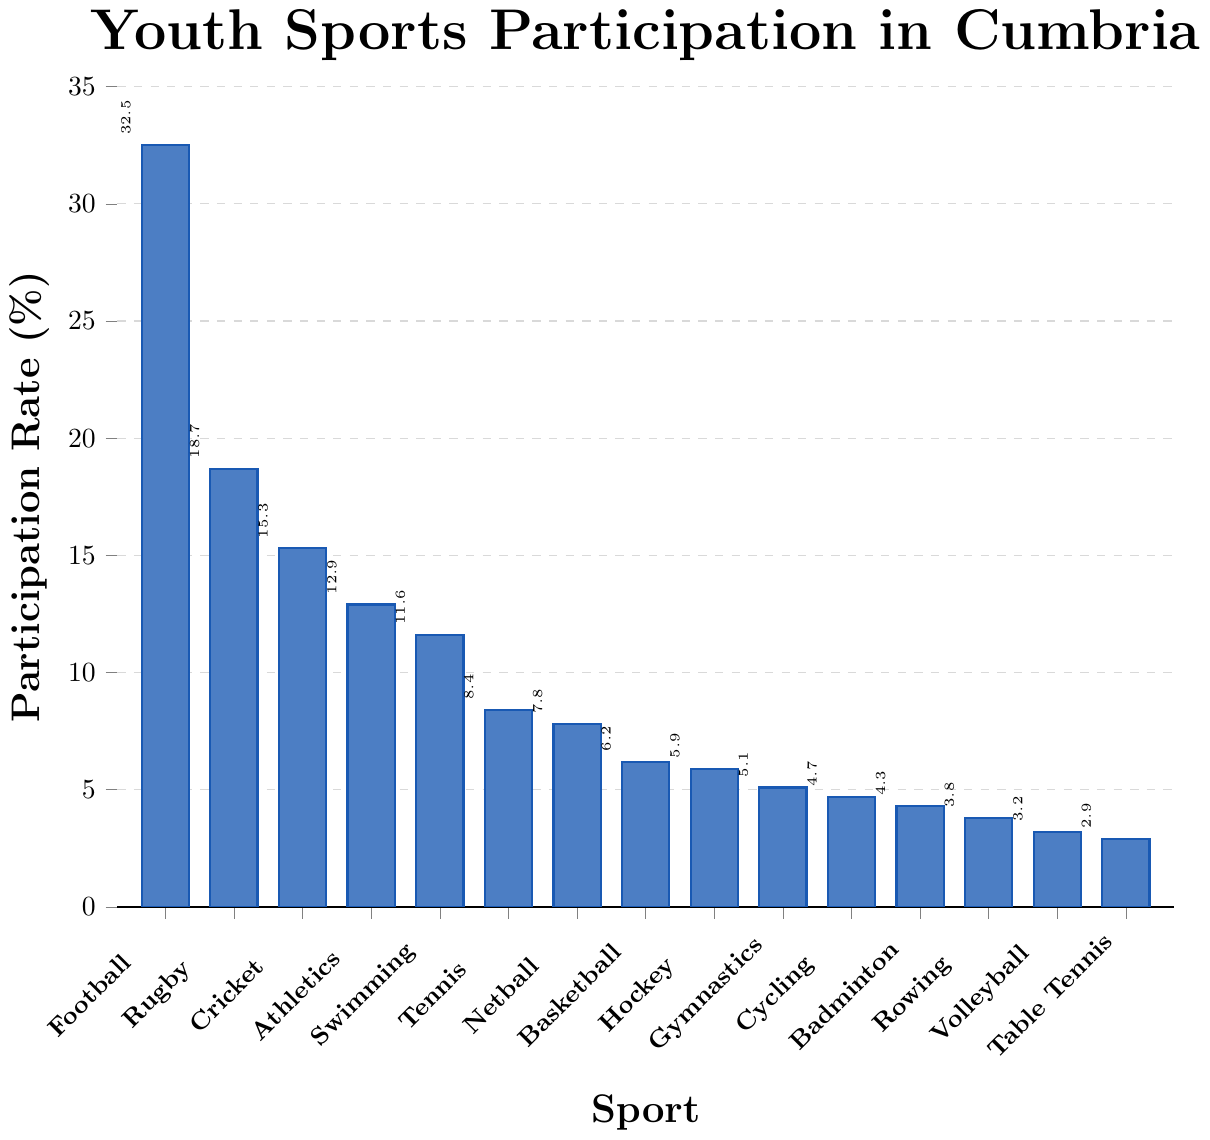Which sport has the highest participation rate? By looking at the height of the bars, Football has the tallest bar, indicating the highest participation rate.
Answer: Football Which sport has the lowest participation rate? By observing the length of the bars, Table Tennis has the shortest bar, indicating the lowest participation rate.
Answer: Table Tennis What's the difference in participation rates between Football and Rugby? Football has a participation rate of 32.5%, and Rugby has a rate of 18.7%. The difference is calculated as 32.5 - 18.7 = 13.8.
Answer: 13.8% How many sports have participation rates below 10%? Observing the bars, the sports with participation rates below 10% are Tennis, Netball, Basketball, Hockey, Gymnastics, Cycling, Badminton, Rowing, Volleyball, and Table Tennis, which totals to 10 sports.
Answer: 10 What is the average participation rate of Athletics and Swimming? Athletics has a participation rate of 12.9% and Swimming has 11.6%. The average is calculated as (12.9 + 11.6) / 2 = 12.25.
Answer: 12.25% Is the participation rate for Netball higher or lower than for Basketball? Netball has a participation rate of 7.8%, while Basketball has 6.2%. Netball’s rate is higher than Basketball’s.
Answer: Higher Which two sports combined have a total participation rate closest to 20%? By summing the rates of Rugby (18.7%) and Cycling (4.7%), the total is 23.4%. A closer match is Athletics (12.9%) and Swimming (11.6%) summing to 24.5%. The closest pair without exceeding is Athletics (12.9%) and Rowing (3.8%) which sum to 16.7%. The closest over 20% are Rugby (18.7%) and Netball (7.8%), totaling 26.5%. There is no exact match.
Answer: No exact pair How does the participation rate of Cricket compare to that of Athletics? Cricket has a participation rate of 15.3%, while Athletics has 12.9%. Cricket’s rate is higher than Athletics’.
Answer: Higher What is the total participation rate of the top three sports? Football (32.5%), Rugby (18.7%), and Cricket (15.3%) are the top three sports. Summing their rates: 32.5 + 18.7 + 15.3 = 66.5%.
Answer: 66.5% What is the median participation rate among all sports? Listing the rates in ascending order: 2.9, 3.2, 3.8, 4.3, 4.7, 5.1, 5.9, 6.2, 7.8, 8.4, 11.6, 12.9, 15.3, 18.7, 32.5. With 15 values, the median is the 8th value, which is 6.2% (Basketball’s rate).
Answer: 6.2% 